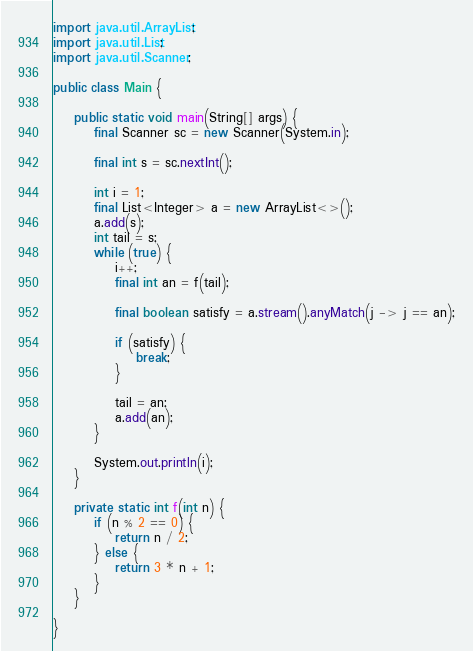<code> <loc_0><loc_0><loc_500><loc_500><_Java_>import java.util.ArrayList;
import java.util.List;
import java.util.Scanner;

public class Main {

	public static void main(String[] args) {
		final Scanner sc = new Scanner(System.in);
		
		final int s = sc.nextInt();
		
		int i = 1;
		final List<Integer> a = new ArrayList<>();
		a.add(s);
		int tail = s;
		while (true) {
			i++;
			final int an = f(tail);
			
			final boolean satisfy = a.stream().anyMatch(j -> j == an);
			
			if (satisfy) {
				break;
			}
			
			tail = an;
			a.add(an);
		}
		
		System.out.println(i);
	}
	
	private static int f(int n) {
		if (n % 2 == 0) {
			return n / 2;
		} else {
			return 3 * n + 1;
		}
	}

}</code> 